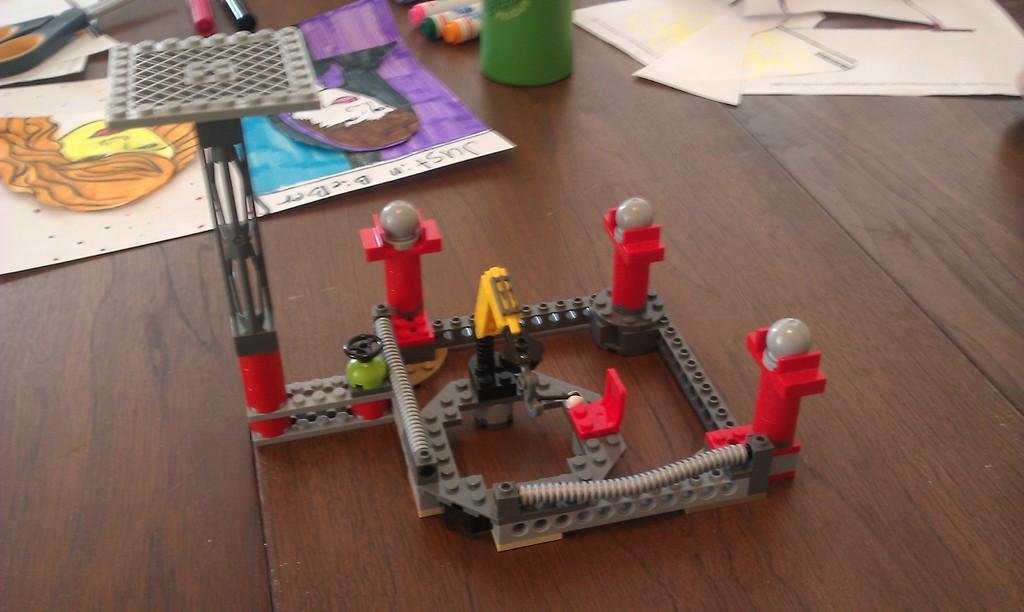In one or two sentences, can you explain what this image depicts? In the image there is a table. On table we can see a paintings,toy,papers,markers and a scissor. 